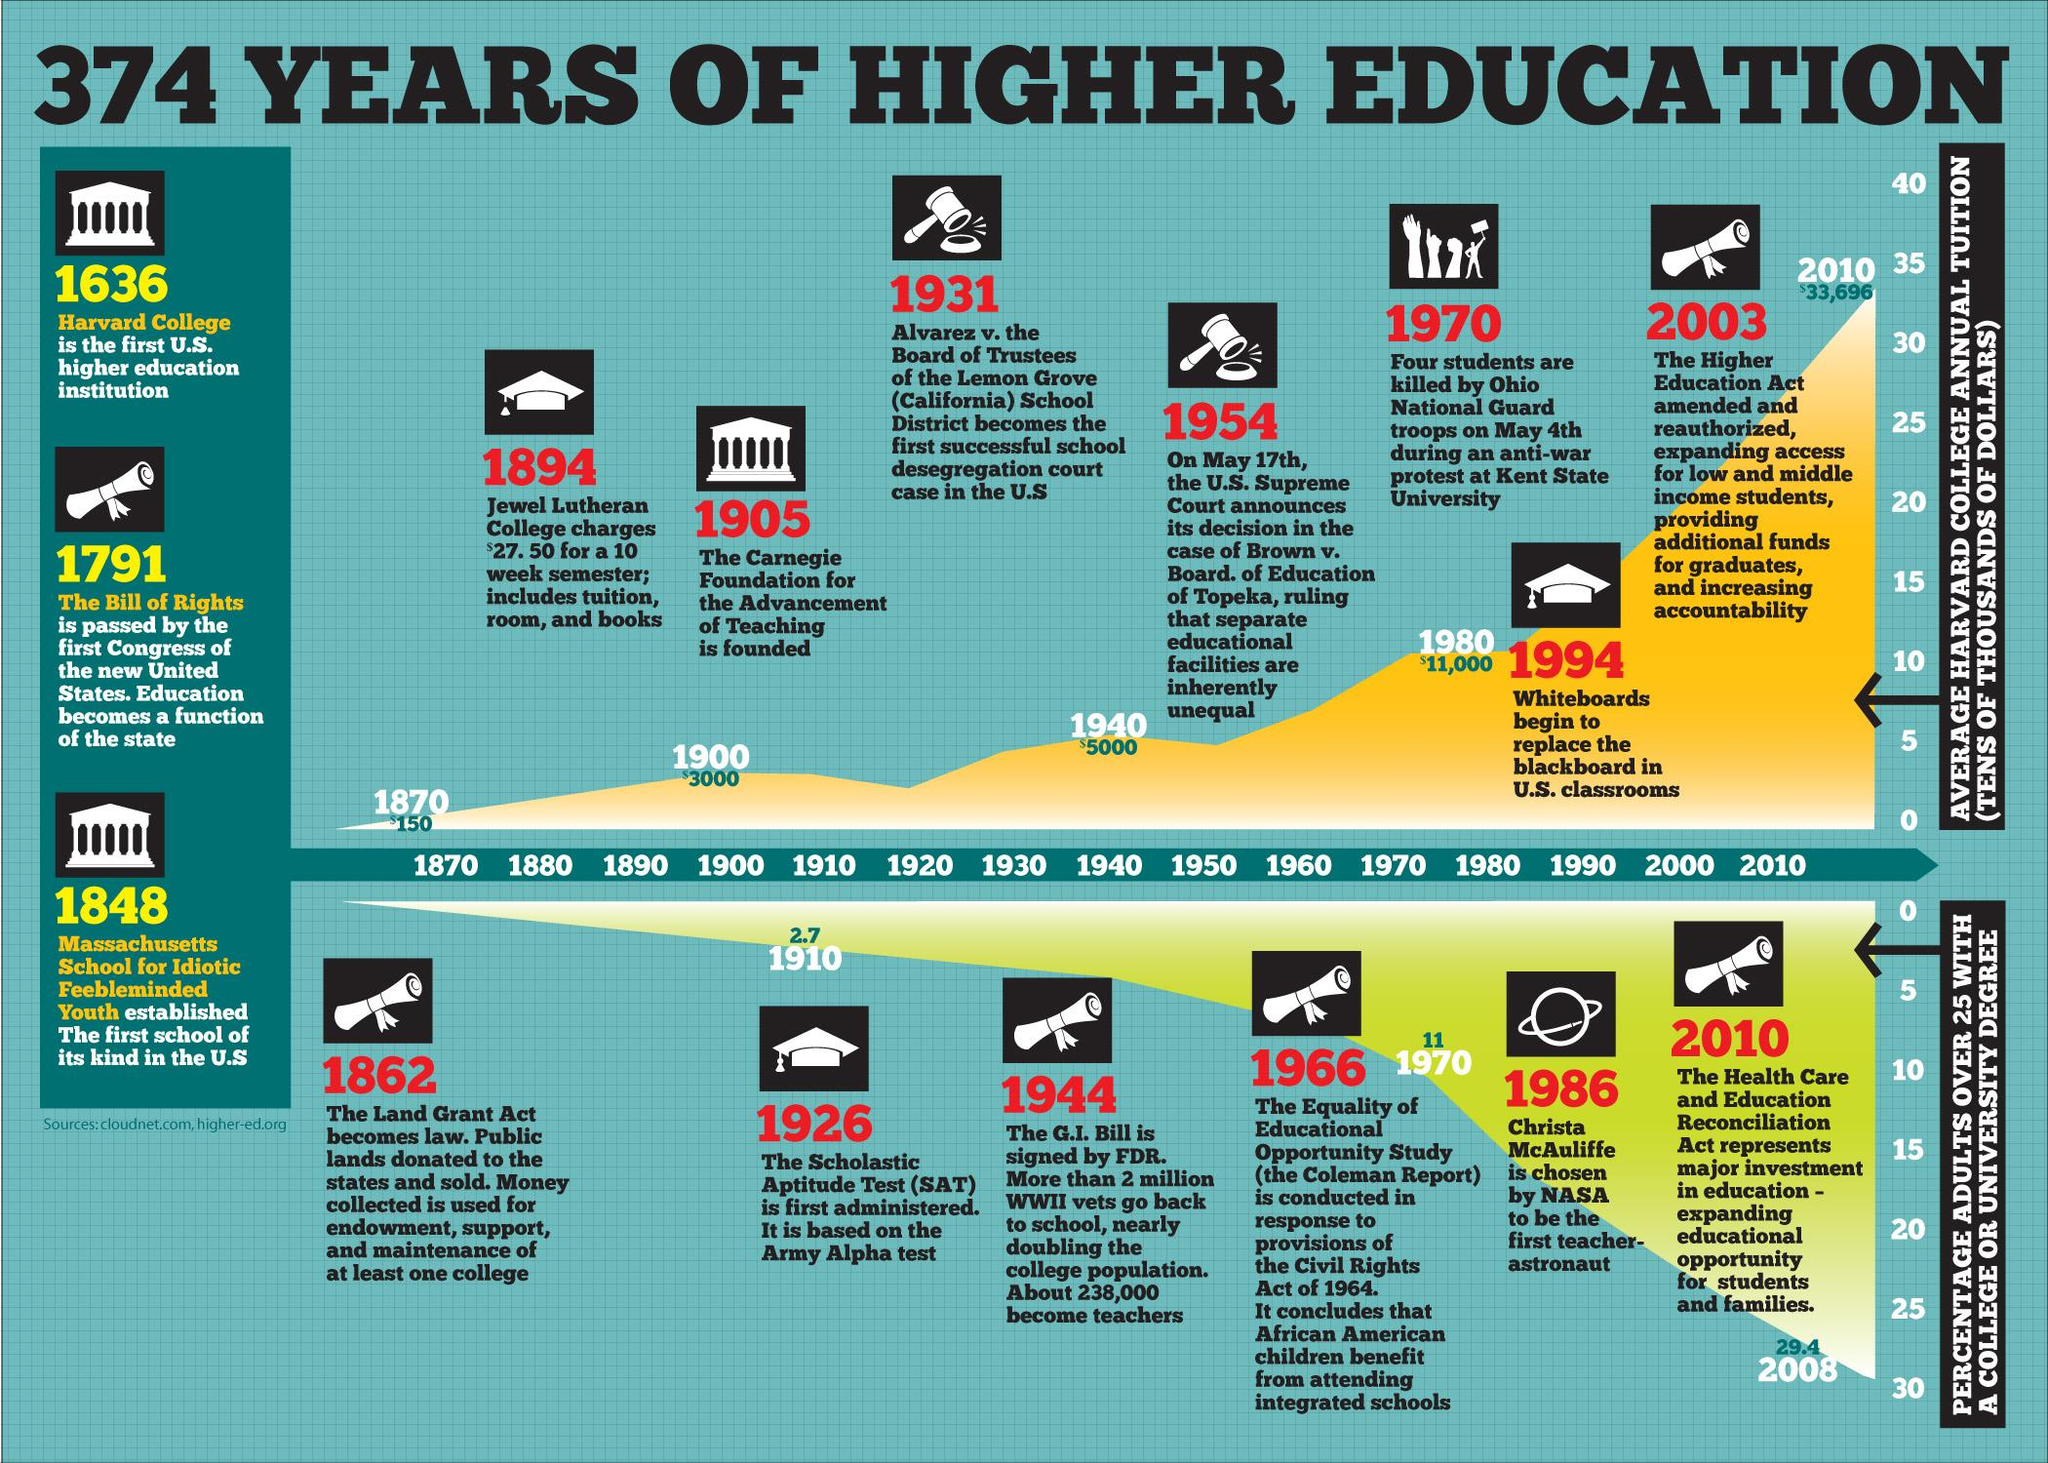Highlight a few significant elements in this photo. In 1970, approximately 11% of adults over the age of 25 held a college or university degree. The Scholastic Aptitude Test was first administered in 1926. In 1940, the average annual tuition at Harvard College was approximately $5,000. The Carnegie Foundation for the Advancement of Teaching was established in 1905. In 2008, it was found that 29.4% of adults over the age of 25 possessed a college or university degree. 